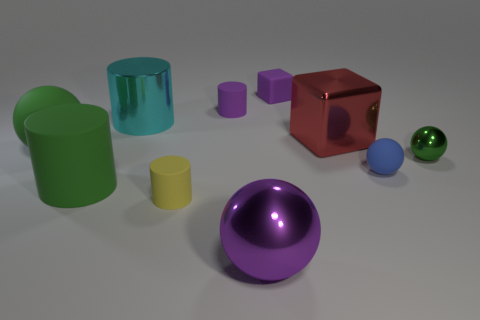What shape is the metallic thing that is in front of the red shiny thing and right of the big purple object?
Your answer should be very brief. Sphere. Is there a blue rubber object that has the same size as the red shiny block?
Offer a terse response. No. There is a small metallic ball; does it have the same color as the matte ball that is on the left side of the purple matte block?
Make the answer very short. Yes. What is the material of the large red object?
Your answer should be very brief. Metal. There is a small cylinder in front of the purple matte cylinder; what is its color?
Make the answer very short. Yellow. How many small blocks have the same color as the big metallic ball?
Make the answer very short. 1. What number of tiny matte objects are in front of the tiny cube and right of the yellow matte thing?
Ensure brevity in your answer.  2. There is a cyan thing that is the same size as the green rubber sphere; what is its shape?
Keep it short and to the point. Cylinder. The red metal block has what size?
Your answer should be compact. Large. There is a tiny object that is to the left of the tiny purple object in front of the cube behind the large cyan cylinder; what is it made of?
Keep it short and to the point. Rubber. 